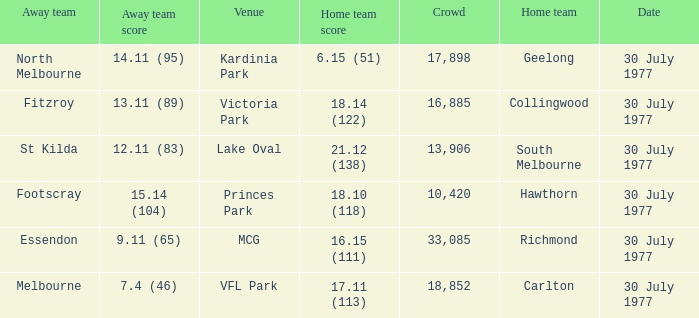What is north melbourne's score as an away side? 14.11 (95). Write the full table. {'header': ['Away team', 'Away team score', 'Venue', 'Home team score', 'Crowd', 'Home team', 'Date'], 'rows': [['North Melbourne', '14.11 (95)', 'Kardinia Park', '6.15 (51)', '17,898', 'Geelong', '30 July 1977'], ['Fitzroy', '13.11 (89)', 'Victoria Park', '18.14 (122)', '16,885', 'Collingwood', '30 July 1977'], ['St Kilda', '12.11 (83)', 'Lake Oval', '21.12 (138)', '13,906', 'South Melbourne', '30 July 1977'], ['Footscray', '15.14 (104)', 'Princes Park', '18.10 (118)', '10,420', 'Hawthorn', '30 July 1977'], ['Essendon', '9.11 (65)', 'MCG', '16.15 (111)', '33,085', 'Richmond', '30 July 1977'], ['Melbourne', '7.4 (46)', 'VFL Park', '17.11 (113)', '18,852', 'Carlton', '30 July 1977']]} 